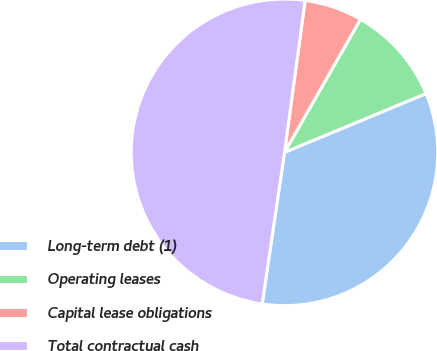<chart> <loc_0><loc_0><loc_500><loc_500><pie_chart><fcel>Long-term debt (1)<fcel>Operating leases<fcel>Capital lease obligations<fcel>Total contractual cash<nl><fcel>33.59%<fcel>10.48%<fcel>6.11%<fcel>49.82%<nl></chart> 